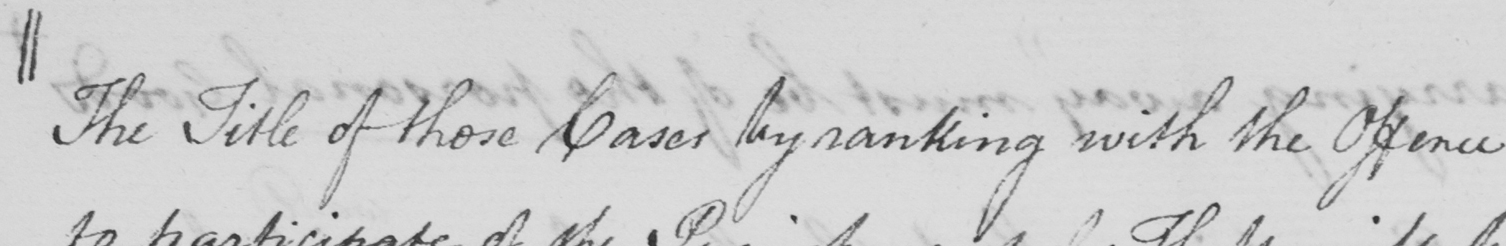Please provide the text content of this handwritten line. || The Title of those Cases by ranking with the Offence 